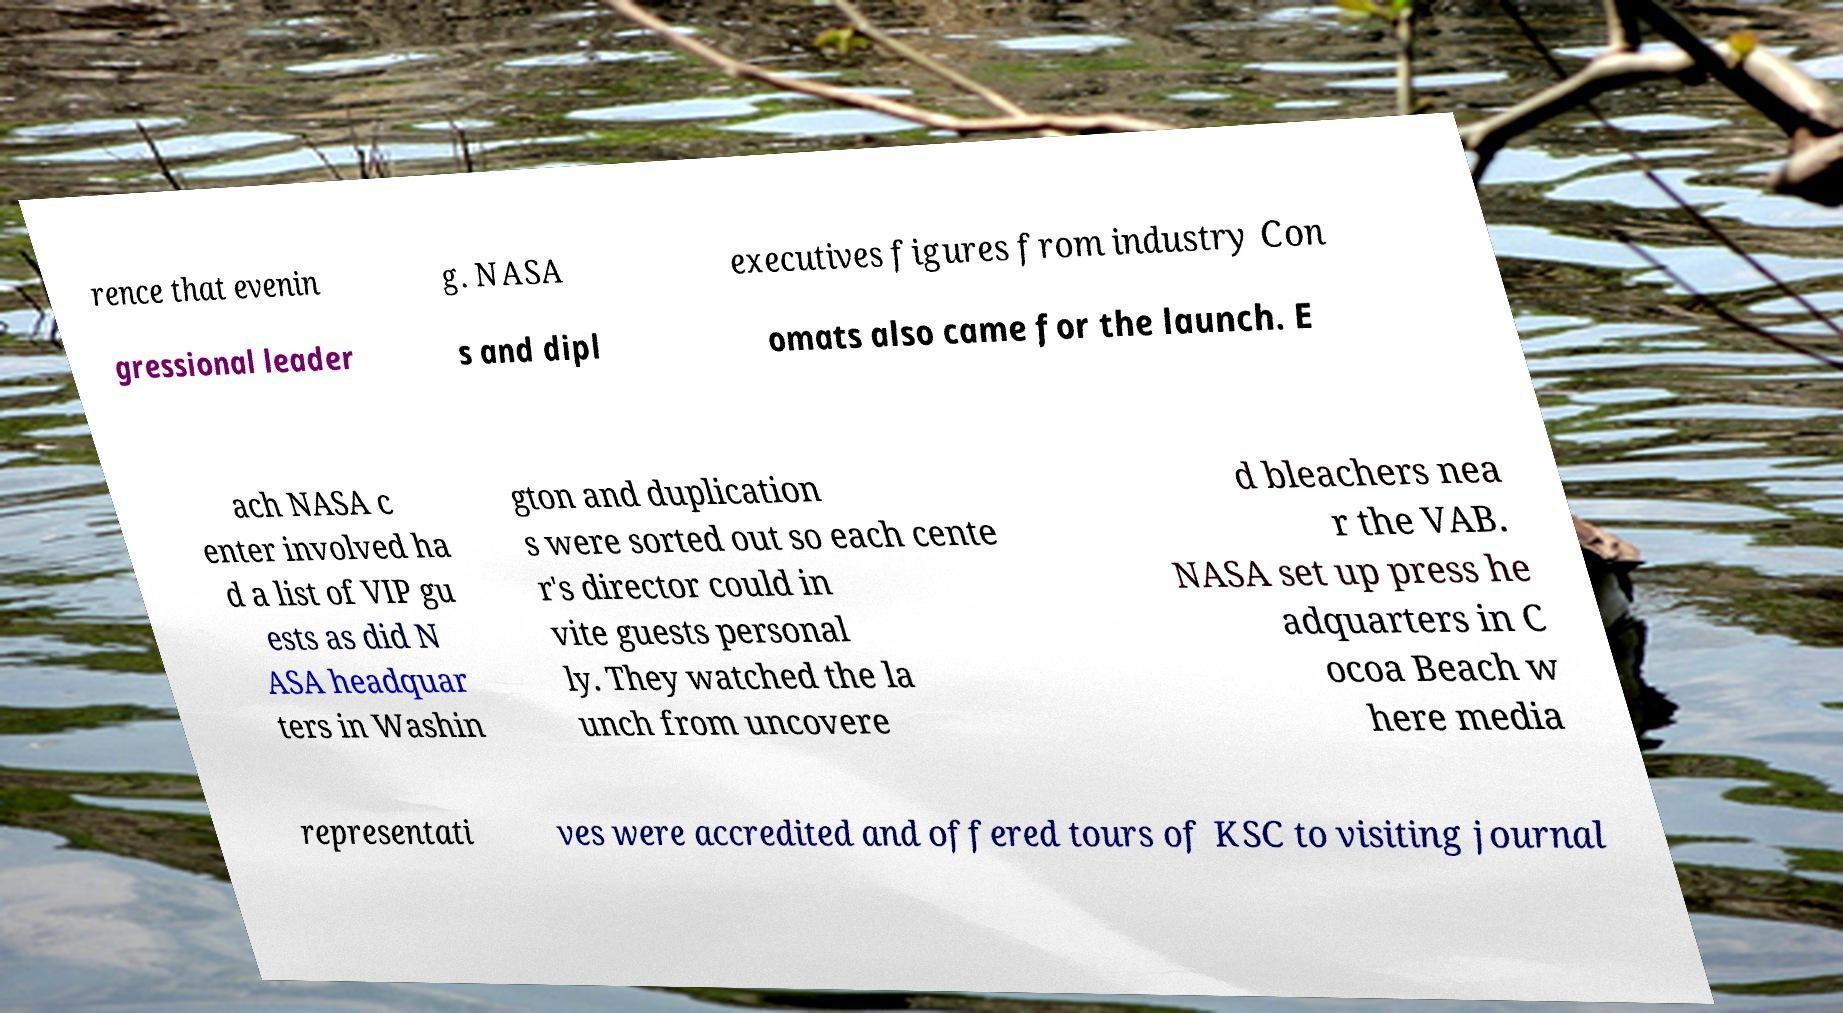What messages or text are displayed in this image? I need them in a readable, typed format. rence that evenin g. NASA executives figures from industry Con gressional leader s and dipl omats also came for the launch. E ach NASA c enter involved ha d a list of VIP gu ests as did N ASA headquar ters in Washin gton and duplication s were sorted out so each cente r's director could in vite guests personal ly. They watched the la unch from uncovere d bleachers nea r the VAB. NASA set up press he adquarters in C ocoa Beach w here media representati ves were accredited and offered tours of KSC to visiting journal 